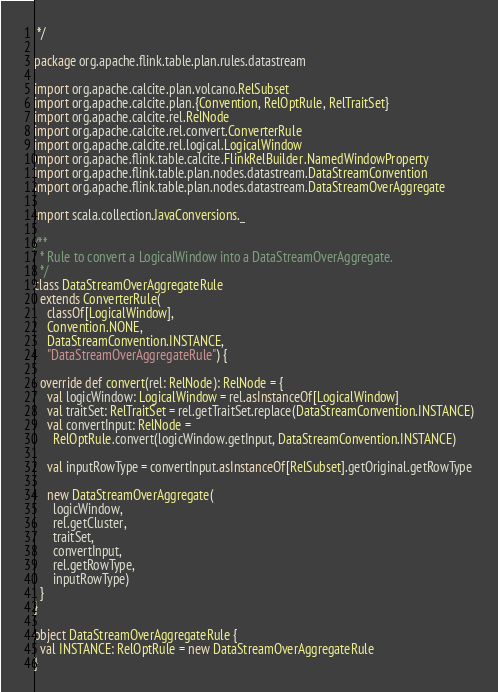<code> <loc_0><loc_0><loc_500><loc_500><_Scala_> */

package org.apache.flink.table.plan.rules.datastream

import org.apache.calcite.plan.volcano.RelSubset
import org.apache.calcite.plan.{Convention, RelOptRule, RelTraitSet}
import org.apache.calcite.rel.RelNode
import org.apache.calcite.rel.convert.ConverterRule
import org.apache.calcite.rel.logical.LogicalWindow
import org.apache.flink.table.calcite.FlinkRelBuilder.NamedWindowProperty
import org.apache.flink.table.plan.nodes.datastream.DataStreamConvention
import org.apache.flink.table.plan.nodes.datastream.DataStreamOverAggregate

import scala.collection.JavaConversions._

/**
  * Rule to convert a LogicalWindow into a DataStreamOverAggregate.
  */
class DataStreamOverAggregateRule
  extends ConverterRule(
    classOf[LogicalWindow],
    Convention.NONE,
    DataStreamConvention.INSTANCE,
    "DataStreamOverAggregateRule") {

  override def convert(rel: RelNode): RelNode = {
    val logicWindow: LogicalWindow = rel.asInstanceOf[LogicalWindow]
    val traitSet: RelTraitSet = rel.getTraitSet.replace(DataStreamConvention.INSTANCE)
    val convertInput: RelNode =
      RelOptRule.convert(logicWindow.getInput, DataStreamConvention.INSTANCE)

    val inputRowType = convertInput.asInstanceOf[RelSubset].getOriginal.getRowType

    new DataStreamOverAggregate(
      logicWindow,
      rel.getCluster,
      traitSet,
      convertInput,
      rel.getRowType,
      inputRowType)
  }
}

object DataStreamOverAggregateRule {
  val INSTANCE: RelOptRule = new DataStreamOverAggregateRule
}

</code> 